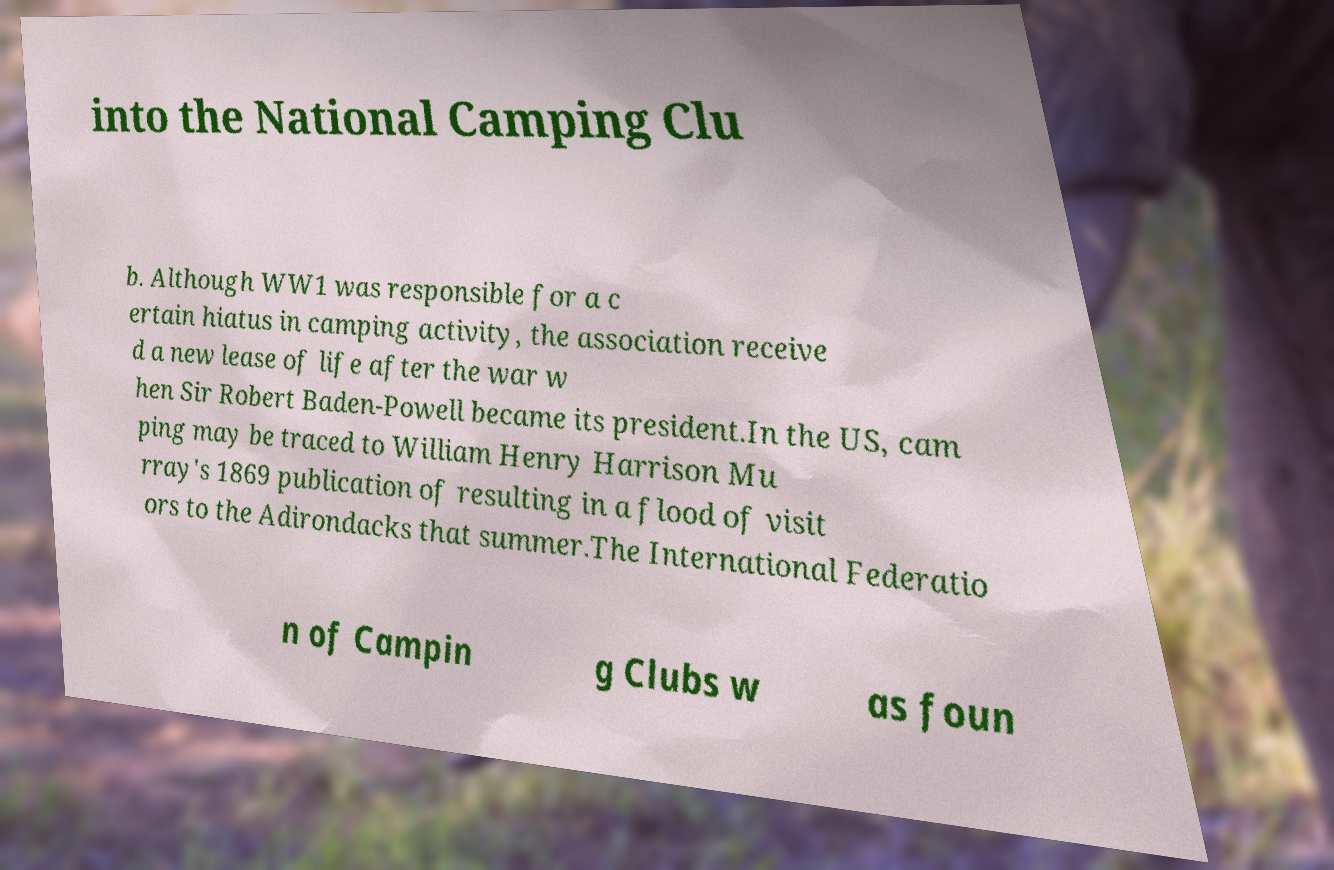Could you assist in decoding the text presented in this image and type it out clearly? into the National Camping Clu b. Although WW1 was responsible for a c ertain hiatus in camping activity, the association receive d a new lease of life after the war w hen Sir Robert Baden-Powell became its president.In the US, cam ping may be traced to William Henry Harrison Mu rray's 1869 publication of resulting in a flood of visit ors to the Adirondacks that summer.The International Federatio n of Campin g Clubs w as foun 